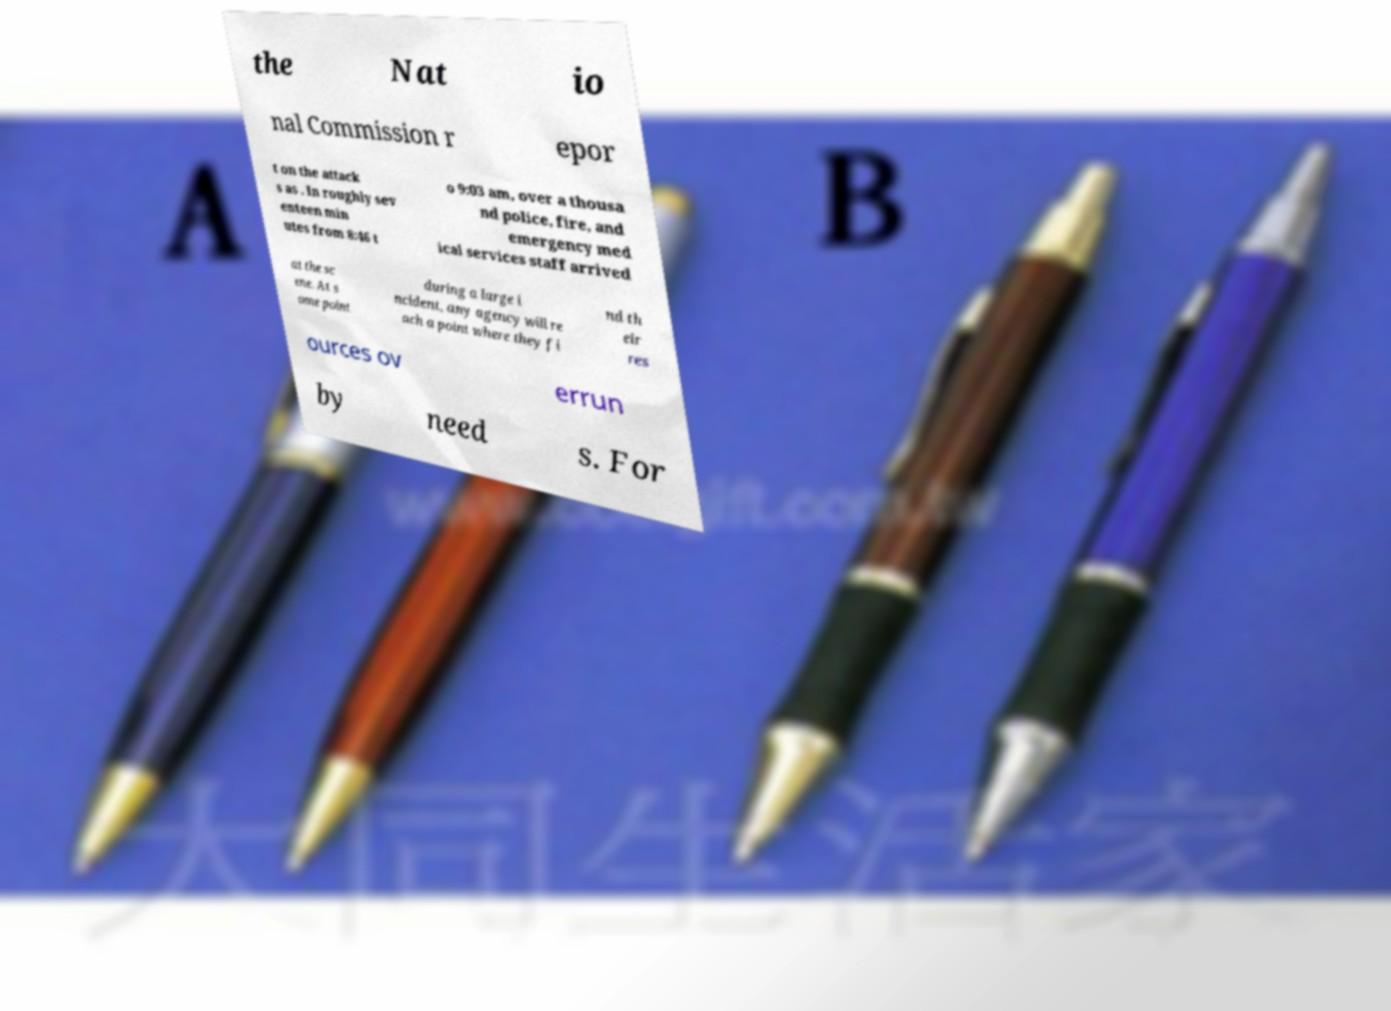Could you assist in decoding the text presented in this image and type it out clearly? the Nat io nal Commission r epor t on the attack s as . In roughly sev enteen min utes from 8:46 t o 9:03 am, over a thousa nd police, fire, and emergency med ical services staff arrived at the sc ene. At s ome point during a large i ncident, any agency will re ach a point where they fi nd th eir res ources ov errun by need s. For 